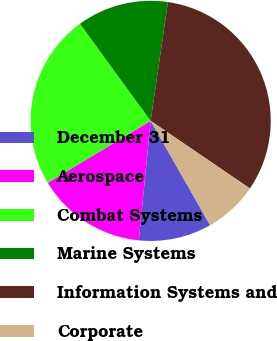Convert chart. <chart><loc_0><loc_0><loc_500><loc_500><pie_chart><fcel>December 31<fcel>Aerospace<fcel>Combat Systems<fcel>Marine Systems<fcel>Information Systems and<fcel>Corporate<nl><fcel>9.82%<fcel>14.81%<fcel>23.6%<fcel>12.32%<fcel>32.22%<fcel>7.24%<nl></chart> 